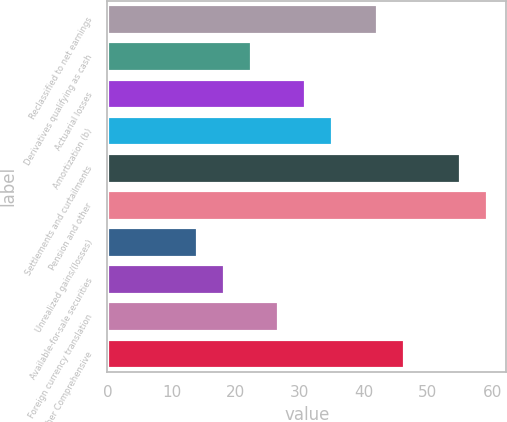Convert chart. <chart><loc_0><loc_0><loc_500><loc_500><bar_chart><fcel>Reclassified to net earnings<fcel>Derivatives qualifying as cash<fcel>Actuarial losses<fcel>Amortization (b)<fcel>Settlements and curtailments<fcel>Pension and other<fcel>Unrealized gains/(losses)<fcel>Available-for-sale securities<fcel>Foreign currency translation<fcel>Total Other Comprehensive<nl><fcel>42<fcel>22.4<fcel>30.8<fcel>35<fcel>55<fcel>59.2<fcel>14<fcel>18.2<fcel>26.6<fcel>46.2<nl></chart> 